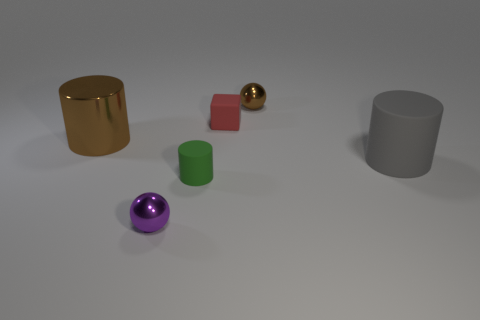The gray cylinder is what size?
Offer a terse response. Large. Is the sphere in front of the brown ball made of the same material as the brown sphere?
Keep it short and to the point. Yes. Are there fewer brown spheres that are in front of the gray matte cylinder than large rubber cylinders?
Your answer should be compact. Yes. What shape is the big object left of the gray cylinder?
Your answer should be compact. Cylinder. There is a gray rubber object that is the same size as the brown cylinder; what is its shape?
Keep it short and to the point. Cylinder. Is there a small brown thing that has the same shape as the tiny purple thing?
Ensure brevity in your answer.  Yes. There is a small rubber object in front of the gray rubber cylinder; does it have the same shape as the brown metal thing that is to the left of the purple sphere?
Your answer should be very brief. Yes. What material is the other cylinder that is the same size as the brown metallic cylinder?
Give a very brief answer. Rubber. What shape is the shiny object that is in front of the cylinder that is left of the tiny rubber cylinder?
Ensure brevity in your answer.  Sphere. What number of objects are either large blue cylinders or tiny shiny balls in front of the small rubber cylinder?
Provide a short and direct response. 1. 